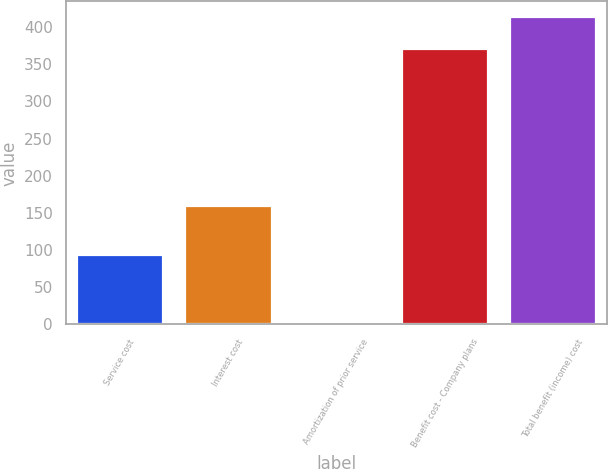Convert chart to OTSL. <chart><loc_0><loc_0><loc_500><loc_500><bar_chart><fcel>Service cost<fcel>Interest cost<fcel>Amortization of prior service<fcel>Benefit cost - Company plans<fcel>Total benefit (income) cost<nl><fcel>93.8<fcel>159.8<fcel>2.7<fcel>370.8<fcel>413.7<nl></chart> 